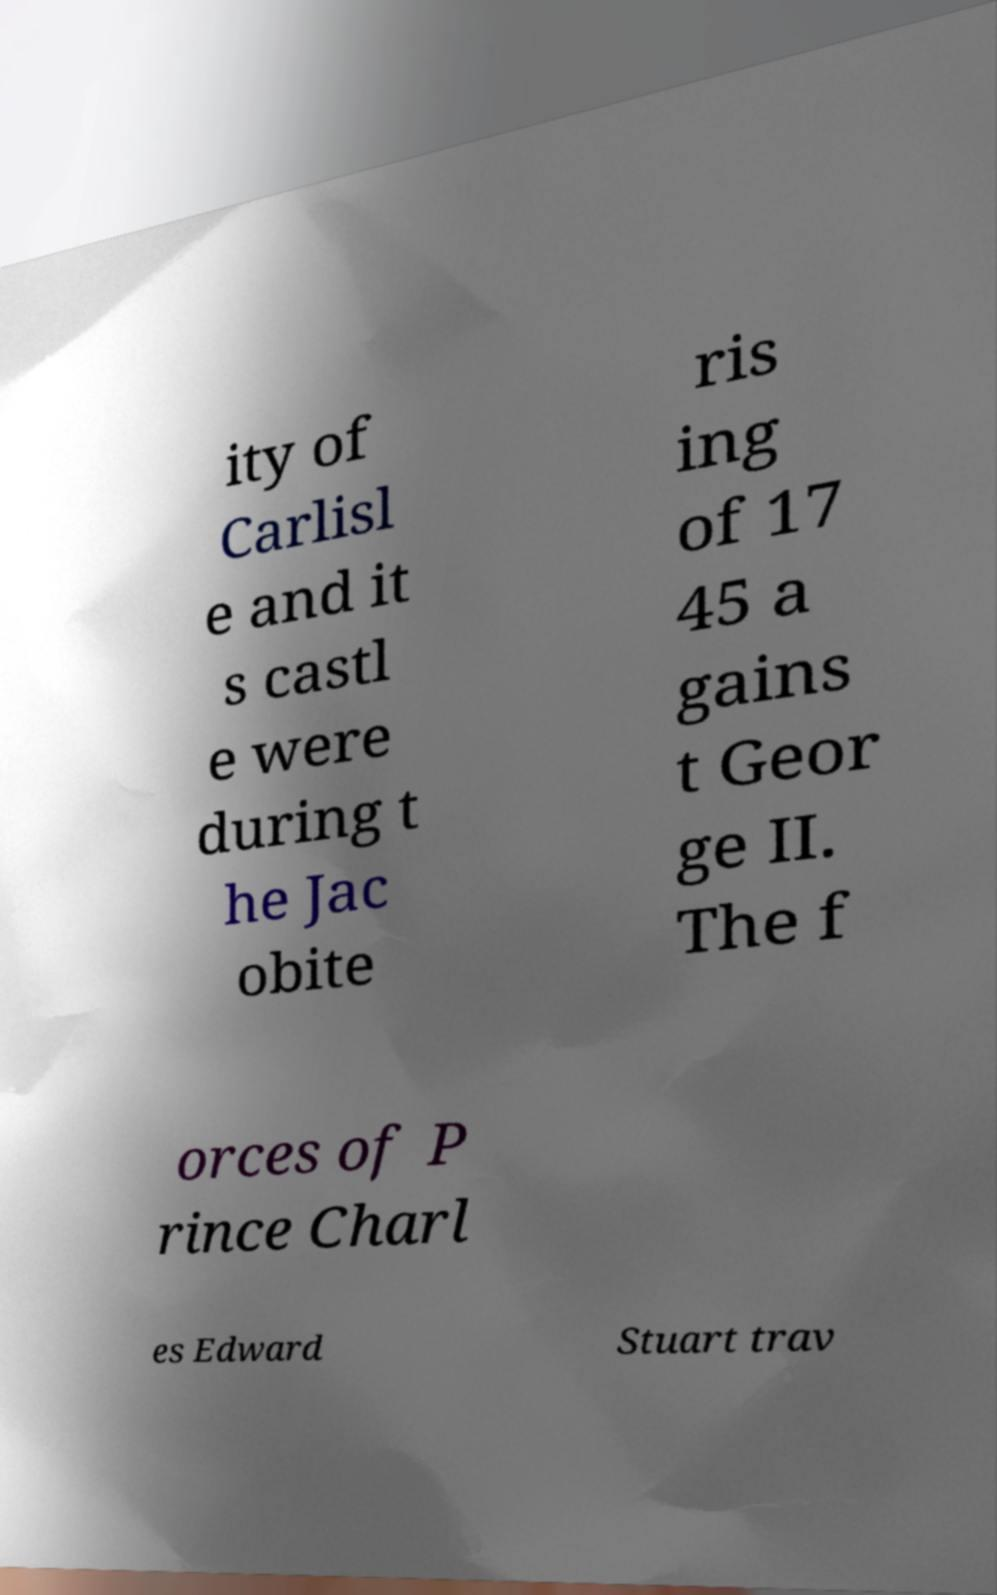Could you assist in decoding the text presented in this image and type it out clearly? ity of Carlisl e and it s castl e were during t he Jac obite ris ing of 17 45 a gains t Geor ge II. The f orces of P rince Charl es Edward Stuart trav 